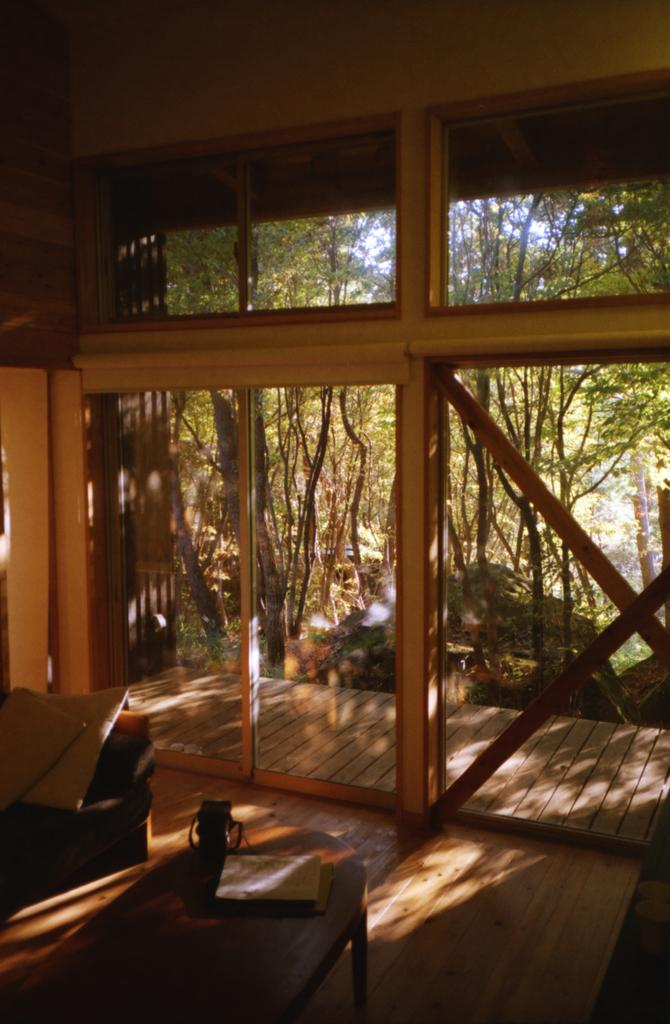What type of furniture can be seen in the image? There are couches in the image. What can be seen through the doors in the image? Trees, plants, grass, and the sky are visible through the doors. How many doors are visible in the image? The provided facts do not specify the number of doors, but there are doors present in the image. Can you tell me how many yaks are grazing on the grass through the doors? There are no yaks present in the image; only trees, plants, grass, and the sky are visible through the doors. 